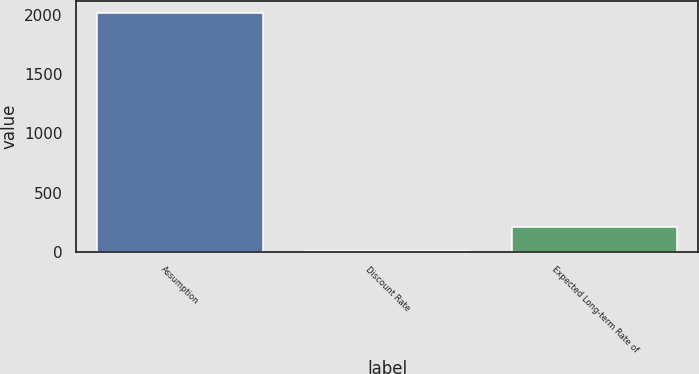Convert chart. <chart><loc_0><loc_0><loc_500><loc_500><bar_chart><fcel>Assumption<fcel>Discount Rate<fcel>Expected Long-term Rate of<nl><fcel>2014<fcel>5<fcel>205.9<nl></chart> 